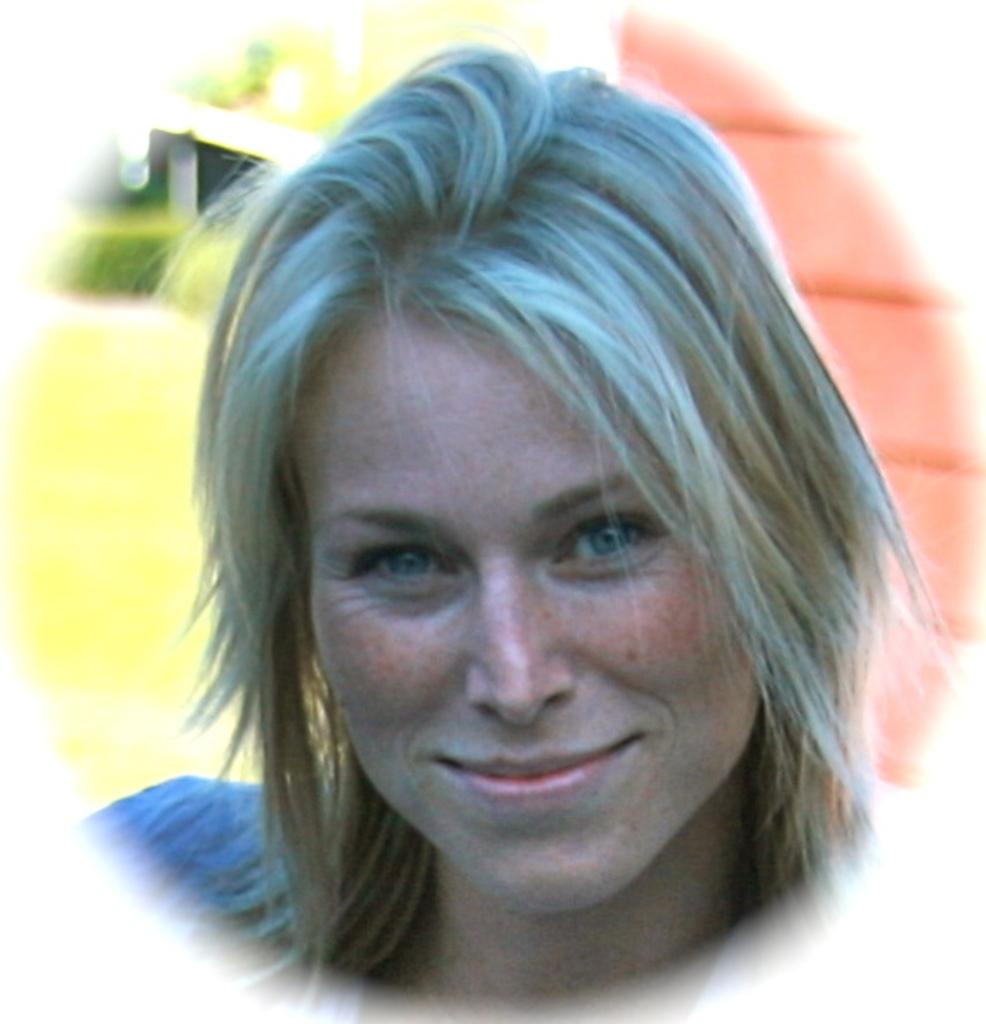Who is the main subject in the image? There is a lady in the image. What is the lady doing in the image? The lady is smiling in the image. Can you describe the background of the image? The background of the image is blurred. What can be seen in the background of the image? There is a wall visible in the background. What type of pump is being used by the lady in the image? There is no pump present in the image. Who is the lady's partner in the image? There is no partner present in the image. 